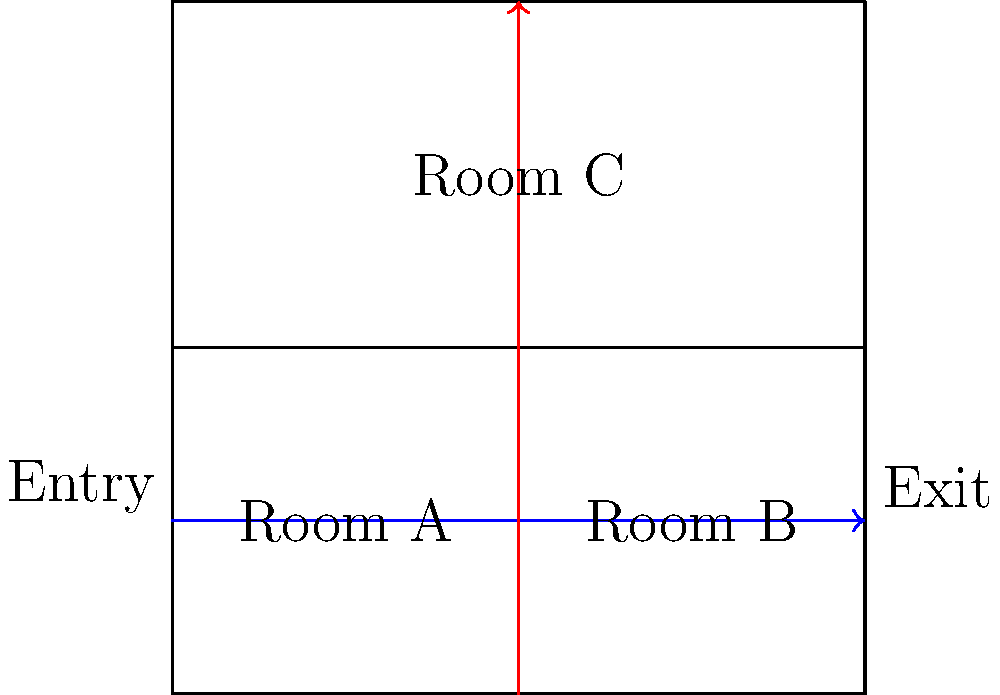As a philanthropist organizing an art exhibition to promote cultural dialogue, you're analyzing visitor flow patterns in a gallery with three rooms (A, B, and C) as shown in the diagram. Two main flow patterns are observed: a horizontal flow (blue arrow) and a vertical flow (red arrow). If 60% of visitors follow the horizontal flow and the rest follow the vertical flow, what percentage of visitors will pass through Room B during their visit? To solve this problem, let's break it down step-by-step:

1) First, we need to understand the flow patterns:
   - Horizontal flow (blue arrow): Visitors pass through Rooms A, B, and C in order.
   - Vertical flow (red arrow): Visitors start in Room A, then go to Room C, bypassing Room B.

2) We're given that:
   - 60% of visitors follow the horizontal flow
   - The remaining 40% follow the vertical flow

3) Now, let's analyze who passes through Room B:
   - All visitors following the horizontal flow (60%) will pass through Room B.
   - None of the visitors following the vertical flow will pass through Room B.

4) Therefore, the percentage of visitors passing through Room B is equal to the percentage following the horizontal flow.

5) We can express this mathematically:
   
   $$ \text{Percentage through Room B} = \text{Percentage following horizontal flow} = 60\% $$

Thus, 60% of visitors will pass through Room B during their visit.
Answer: 60% 